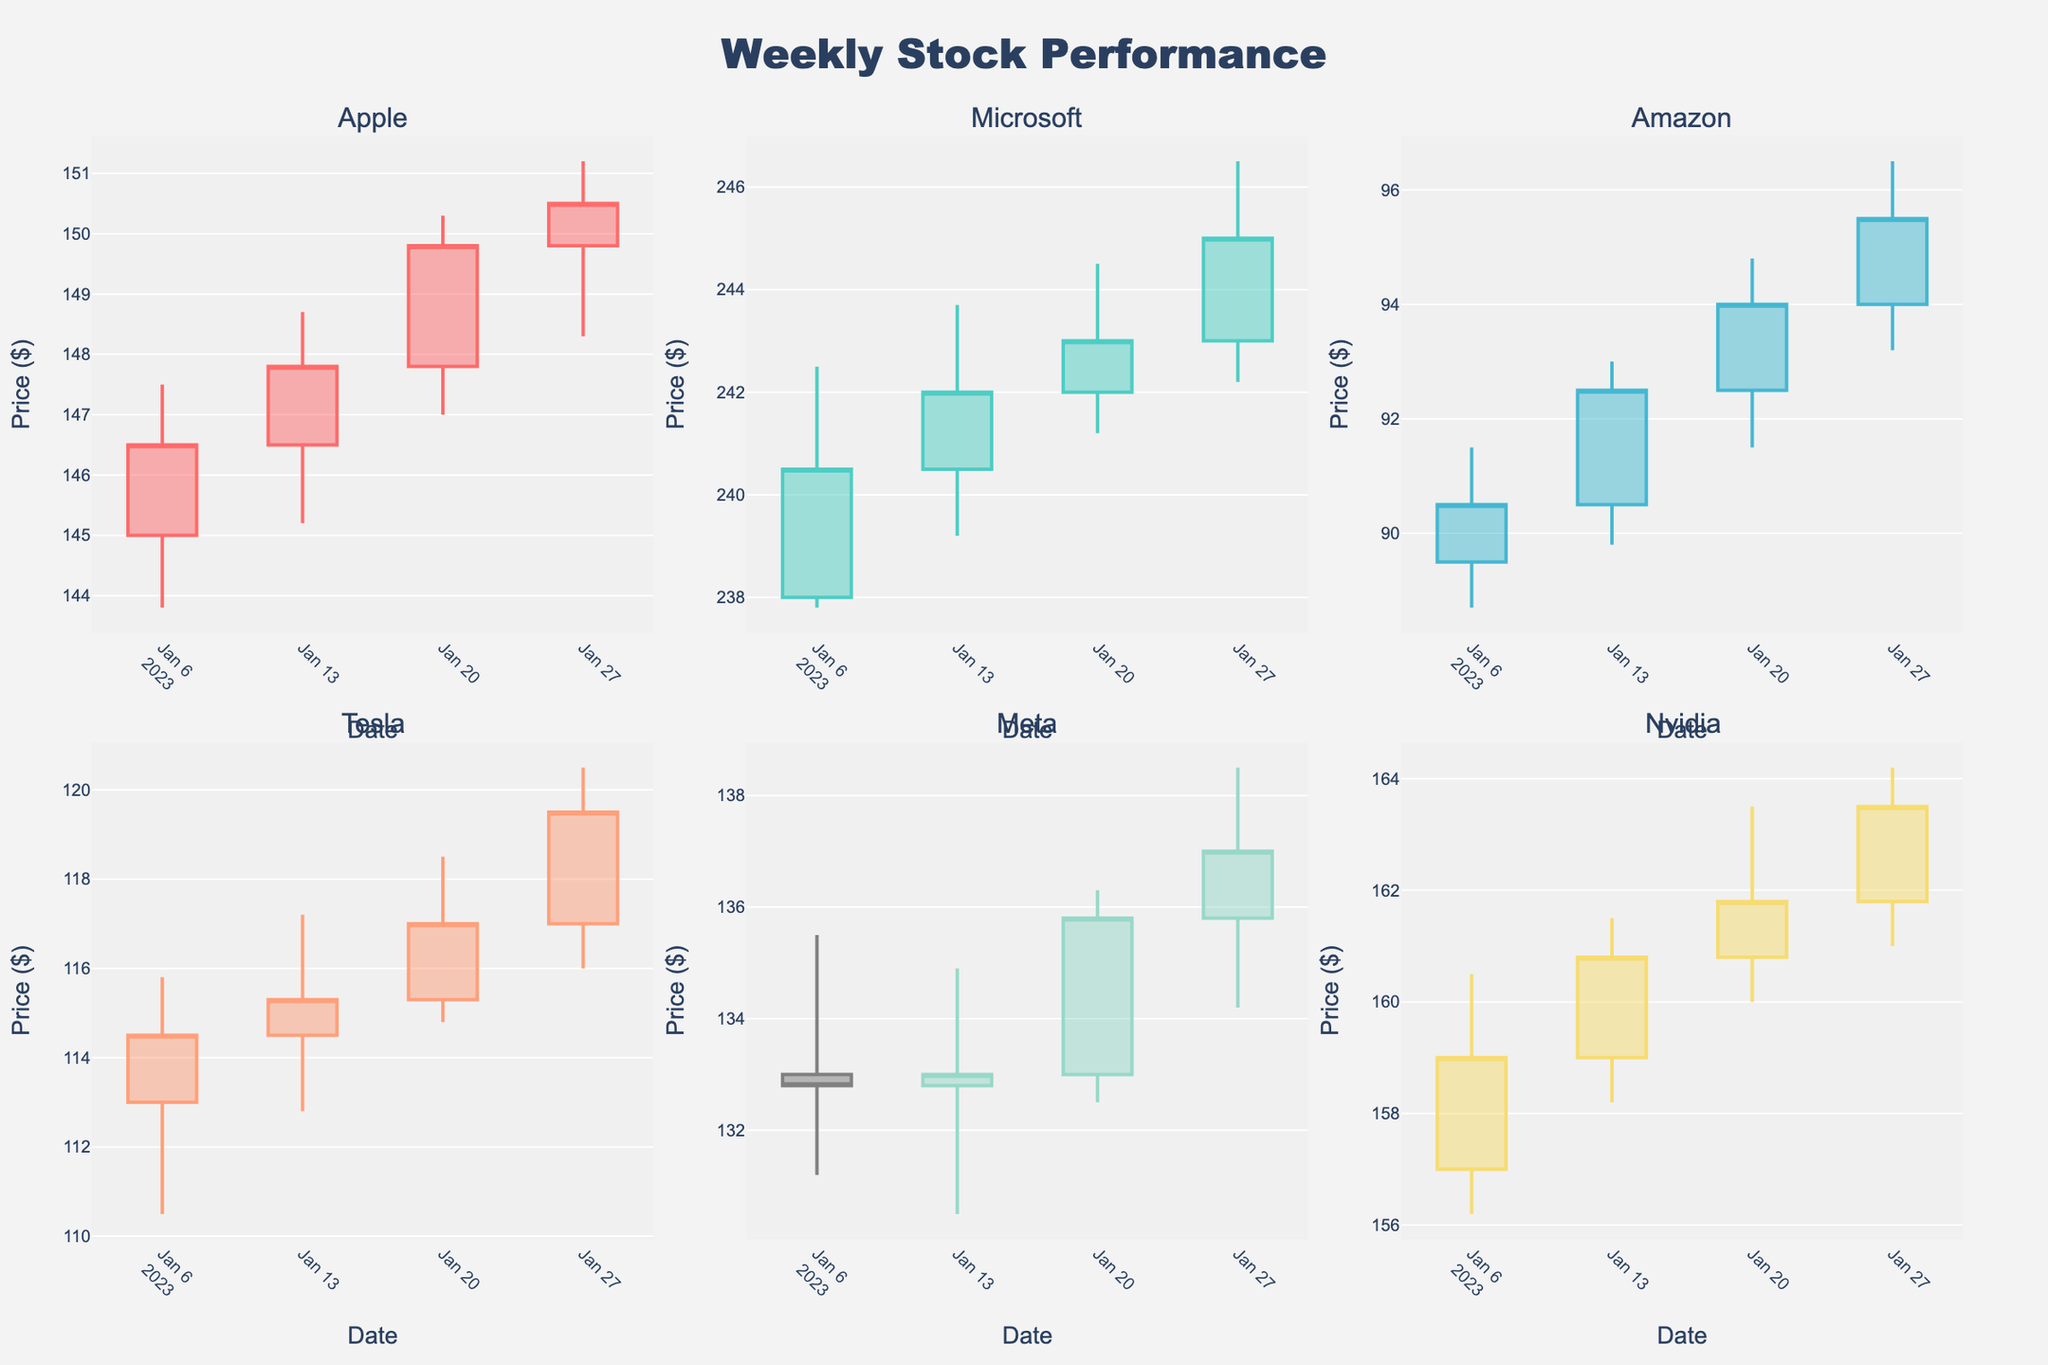What is the title of the plot? The title of the plot is mentioned at the top of the figure.
Answer: Weekly Stock Performance How many stocks are presented in the figure? There are six different stocks represented in the figure.
Answer: Six Which stock shows the highest closing price for any week in January 2023? By looking at the highest points on the candlestick plots, you can see that Microsoft has the highest closing price at around $245.00 on January 27, 2023.
Answer: Microsoft Did Apple close lower than it opened for any week in January 2023? Apple opened at $145.00 and closed at $146.50 on January 06, opened at $146.50 and closed at $147.80 on January 13, opened at $147.80 and closed at $149.80 on January 20, and opened at $149.80 and closed at $150.50 on January 27. In all these cases, the close prices are higher than the open prices.
Answer: No Which stock had the most consistent performance in January 2023 in terms of weekly closing prices? We look at the variance in the weekly closing prices. Stocks with the least fluctuation in closing prices have consistent performance. Examining the plots, Meta consistently fluctuates around $132.80 to $137.00, showing less variability compared to other stocks.
Answer: Meta What was the closing price for Tesla on January 13, 2023? Check the candlestick plot for Tesla on the given date (January 13, 2023). The closing price is at the top end of the body of the candlestick.
Answer: $115.30 Compare the closing price trends of Amazon and Nvidia throughout January 2023. How do they differ? Amazon's closing prices show an upward trend, starting from $90.50 and reaching $95.50. Nvidia's closing prices also increase consistently, starting at $159.00 and concluding at $163.50. Although both show an upward trend, Nvidia's prices are consistently higher and range higher throughout January.
Answer: Nvidia has higher prices and both show an upward trend Which week showed the greatest increase in closing price for Amazon? Calculate the weekly increases for Amazon by subtracting the closing prices of the previous week. The increase from January 20 ($94.00) to January 27 ($95.50) is $1.50, from January 13 ($92.50) to January 20 ($94.00) is $1.50, and from January 06 ($90.50) to January 13 ($92.50) is $2.00. Thus, the greatest increase is in the week of January 13, 2023.
Answer: Week of January 13, 2023 What is the average closing price of Microsoft in January 2023? Add the closing prices of Microsoft for each week: $240.50, $242.00, $243.00, and $245.00, which sums up to $970.50. Then divide by the number of weeks (4): $970.50 / 4 = $242.63.
Answer: $242.63 